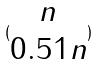Convert formula to latex. <formula><loc_0><loc_0><loc_500><loc_500>( \begin{matrix} n \\ 0 . 5 1 n \end{matrix} )</formula> 